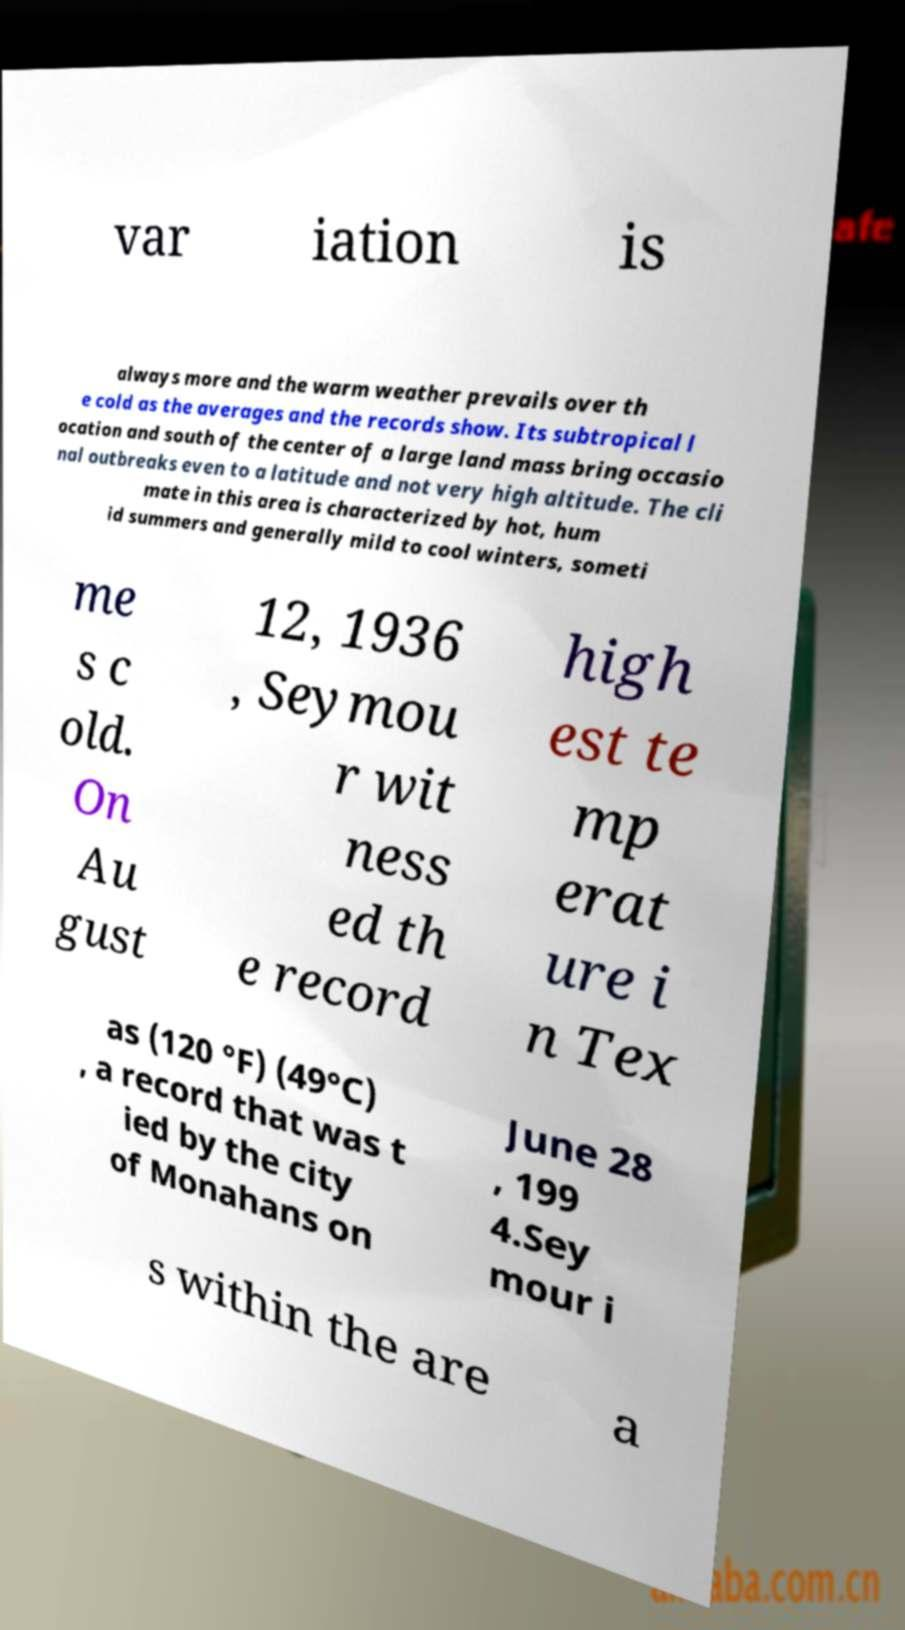Can you read and provide the text displayed in the image?This photo seems to have some interesting text. Can you extract and type it out for me? var iation is always more and the warm weather prevails over th e cold as the averages and the records show. Its subtropical l ocation and south of the center of a large land mass bring occasio nal outbreaks even to a latitude and not very high altitude. The cli mate in this area is characterized by hot, hum id summers and generally mild to cool winters, someti me s c old. On Au gust 12, 1936 , Seymou r wit ness ed th e record high est te mp erat ure i n Tex as (120 °F) (49°C) , a record that was t ied by the city of Monahans on June 28 , 199 4.Sey mour i s within the are a 